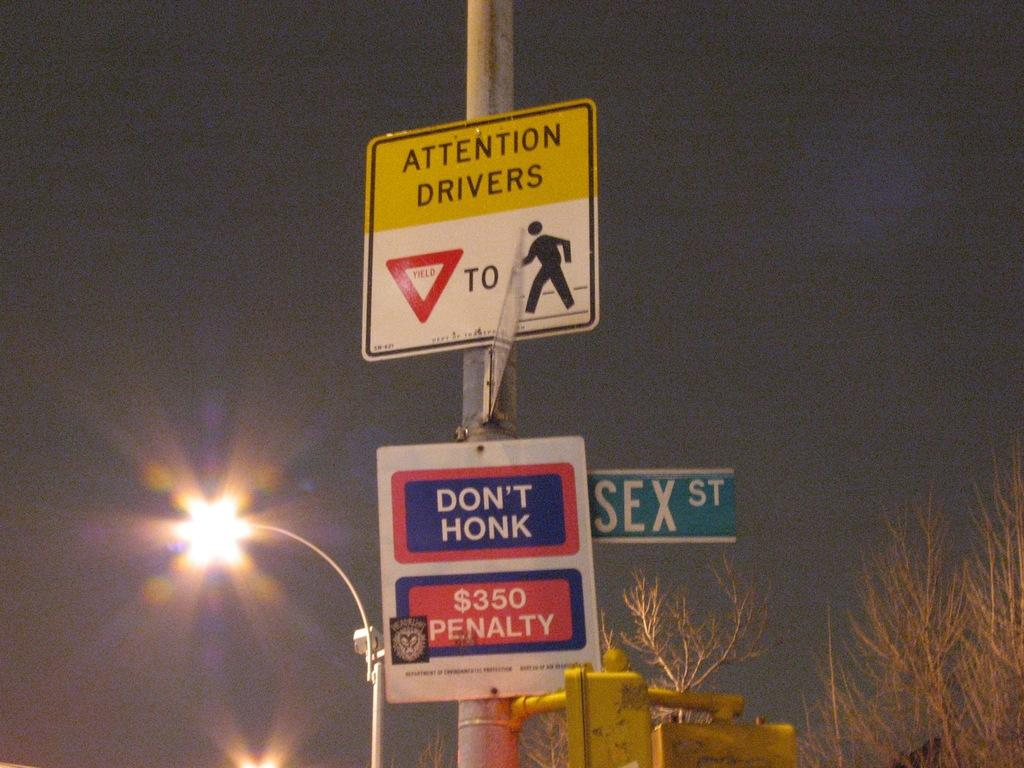Provide a one-sentence caption for the provided image. A street lamp glows behind a pole with an attention drivers sign and a no honking sign. 